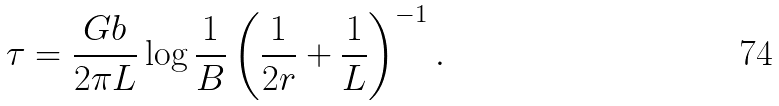Convert formula to latex. <formula><loc_0><loc_0><loc_500><loc_500>\tau = \frac { G b } { 2 \pi L } \log \frac { 1 } { B } \left ( \frac { 1 } { 2 r } + \frac { 1 } { L } \right ) ^ { - 1 } .</formula> 